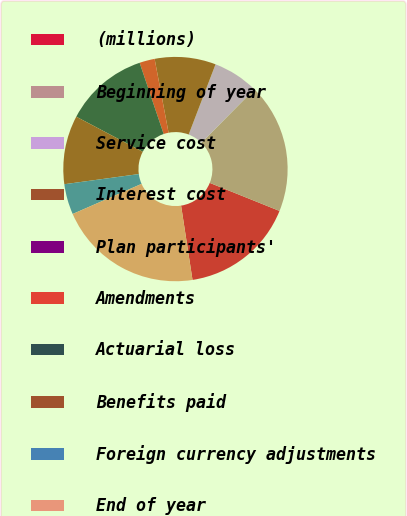<chart> <loc_0><loc_0><loc_500><loc_500><pie_chart><fcel>(millions)<fcel>Beginning of year<fcel>Service cost<fcel>Interest cost<fcel>Plan participants'<fcel>Amendments<fcel>Actuarial loss<fcel>Benefits paid<fcel>Foreign currency adjustments<fcel>End of year<nl><fcel>16.48%<fcel>18.68%<fcel>6.59%<fcel>8.79%<fcel>0.0%<fcel>2.2%<fcel>12.09%<fcel>9.89%<fcel>4.4%<fcel>20.87%<nl></chart> 